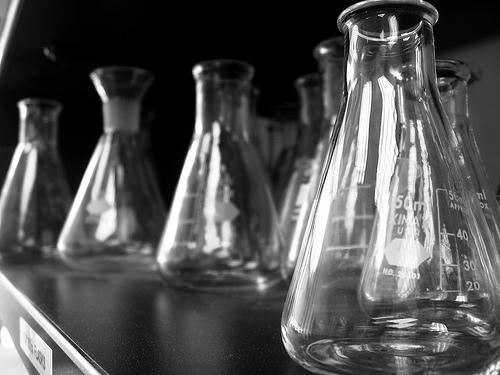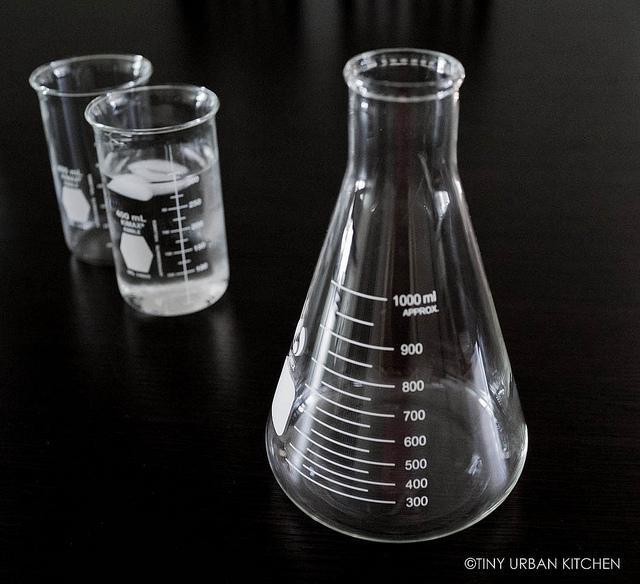The first image is the image on the left, the second image is the image on the right. Examine the images to the left and right. Is the description "All of the containers are the same basic shape." accurate? Answer yes or no. No. The first image is the image on the left, the second image is the image on the right. For the images displayed, is the sentence "The right image includes at least one cylindrical beaker made of clear glass, and the left image includes multiple glass beakers with wide bases that taper to a narrower top." factually correct? Answer yes or no. Yes. 